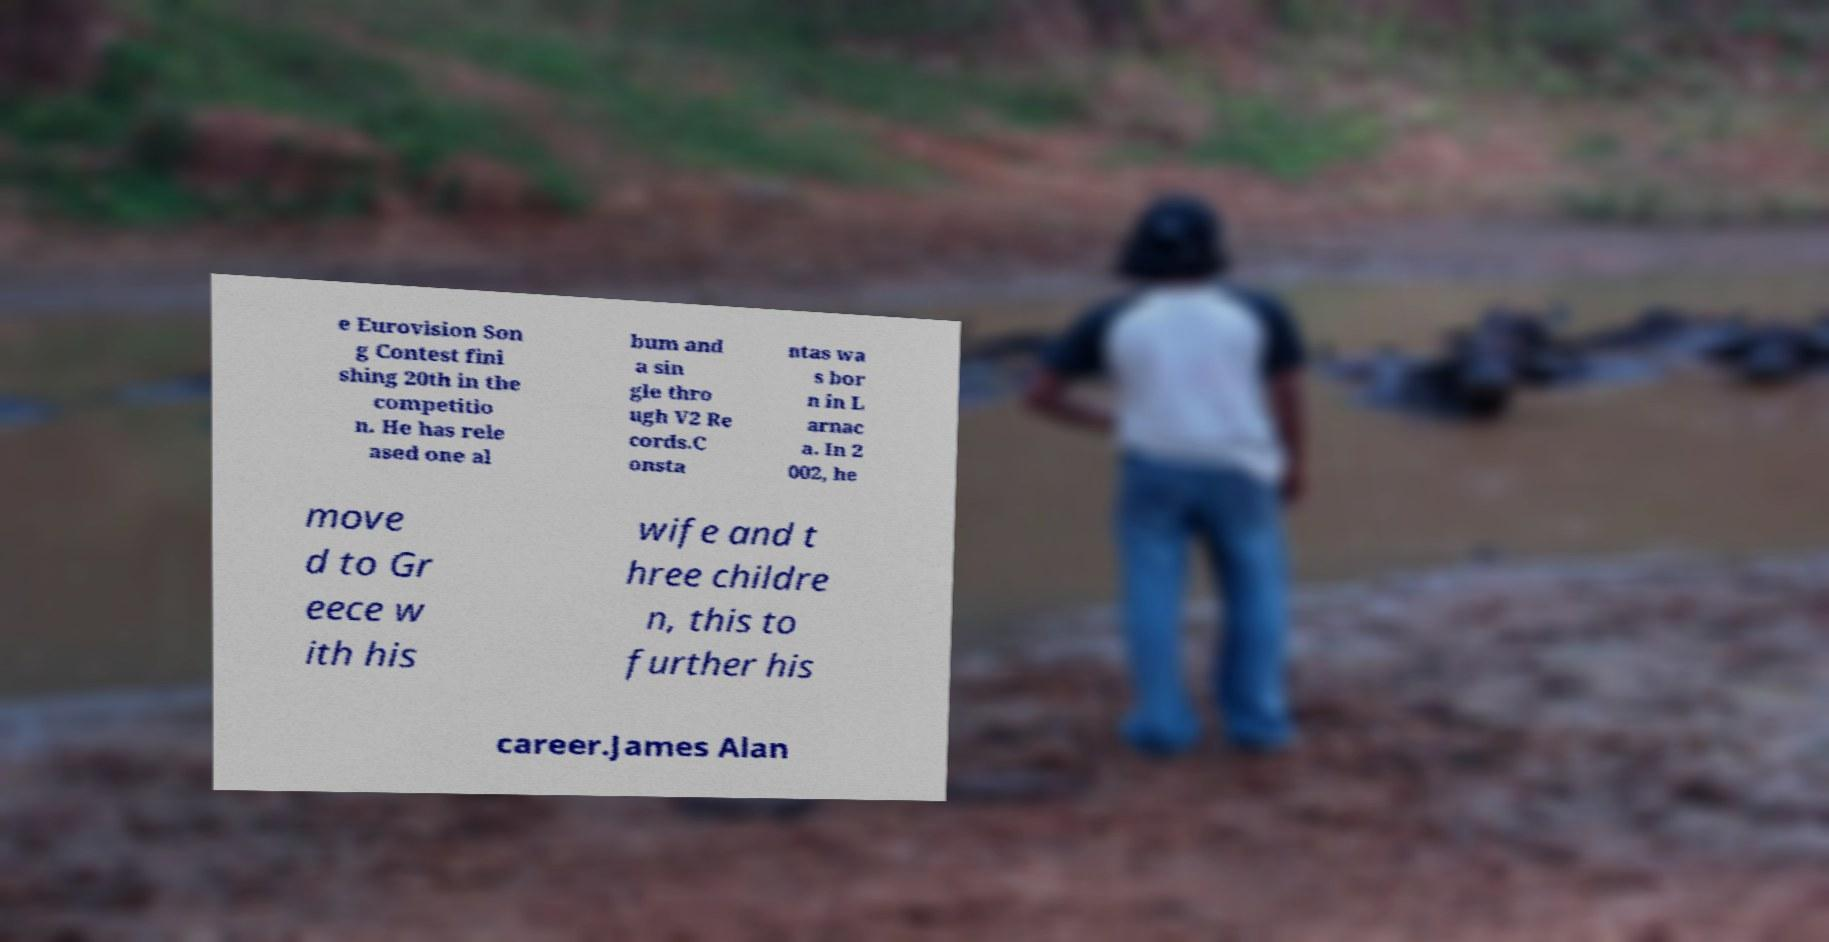Could you assist in decoding the text presented in this image and type it out clearly? e Eurovision Son g Contest fini shing 20th in the competitio n. He has rele ased one al bum and a sin gle thro ugh V2 Re cords.C onsta ntas wa s bor n in L arnac a. In 2 002, he move d to Gr eece w ith his wife and t hree childre n, this to further his career.James Alan 